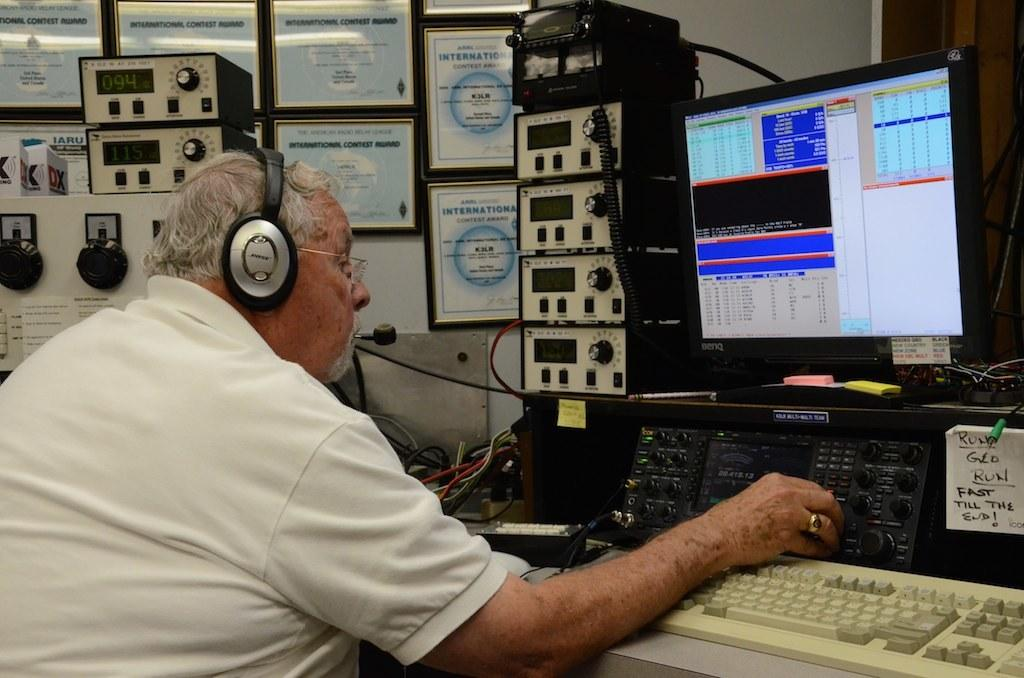<image>
Give a short and clear explanation of the subsequent image. A man wearing headphones is starring at a monitor and a note saying fast till the end is next to him. 